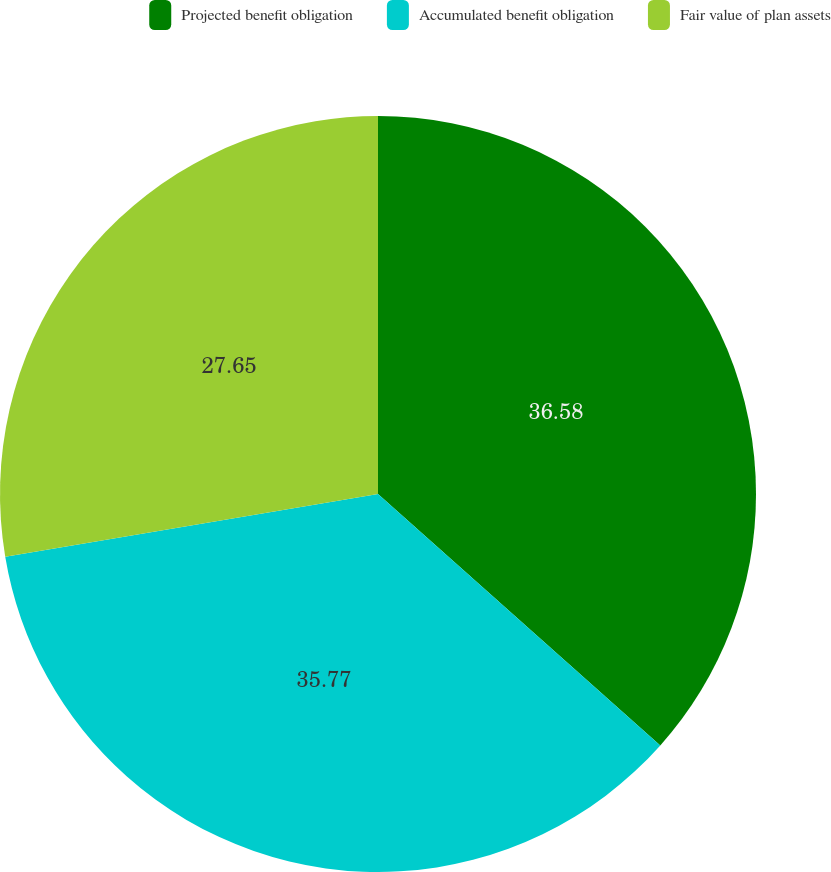<chart> <loc_0><loc_0><loc_500><loc_500><pie_chart><fcel>Projected benefit obligation<fcel>Accumulated benefit obligation<fcel>Fair value of plan assets<nl><fcel>36.58%<fcel>35.77%<fcel>27.65%<nl></chart> 